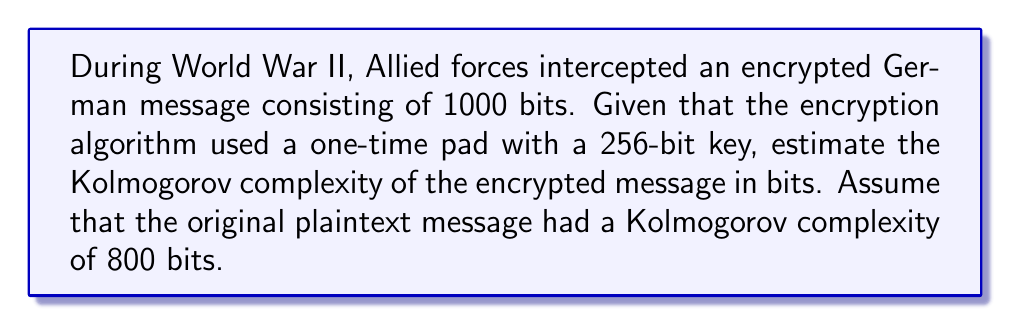Give your solution to this math problem. To solve this problem, we need to understand the concept of Kolmogorov complexity and how encryption affects it. Let's break it down step-by-step:

1) Kolmogorov complexity is a measure of the computational resources needed to specify an object. In this case, we're dealing with a message.

2) The original plaintext message has a Kolmogorov complexity of 800 bits. This means that the shortest program that can generate this message is approximately 800 bits long.

3) The message was encrypted using a one-time pad with a 256-bit key. A one-time pad is a perfect encryption method that XORs the plaintext with a random key.

4) To describe the encrypted message, we need:
   a) The original message (800 bits)
   b) The encryption algorithm (negligible, as it's assumed to be known)
   c) The encryption key (256 bits)

5) The Kolmogorov complexity of the encrypted message is approximately the sum of these components:

   $$K(encrypted) \approx K(plaintext) + K(key)$$

6) Substituting the values:

   $$K(encrypted) \approx 800 + 256 = 1056\text{ bits}$$

7) This estimate is an upper bound. The actual Kolmogorov complexity might be slightly lower due to potential optimizations in describing the combination of the message and key.

It's important to note that while the encrypted message is 1000 bits long, its Kolmogorov complexity is higher. This is because to reproduce the encrypted message, we need both the original message and the key, which together require more information than the encrypted message itself.
Answer: The estimated Kolmogorov complexity of the encrypted message is approximately 1056 bits. 